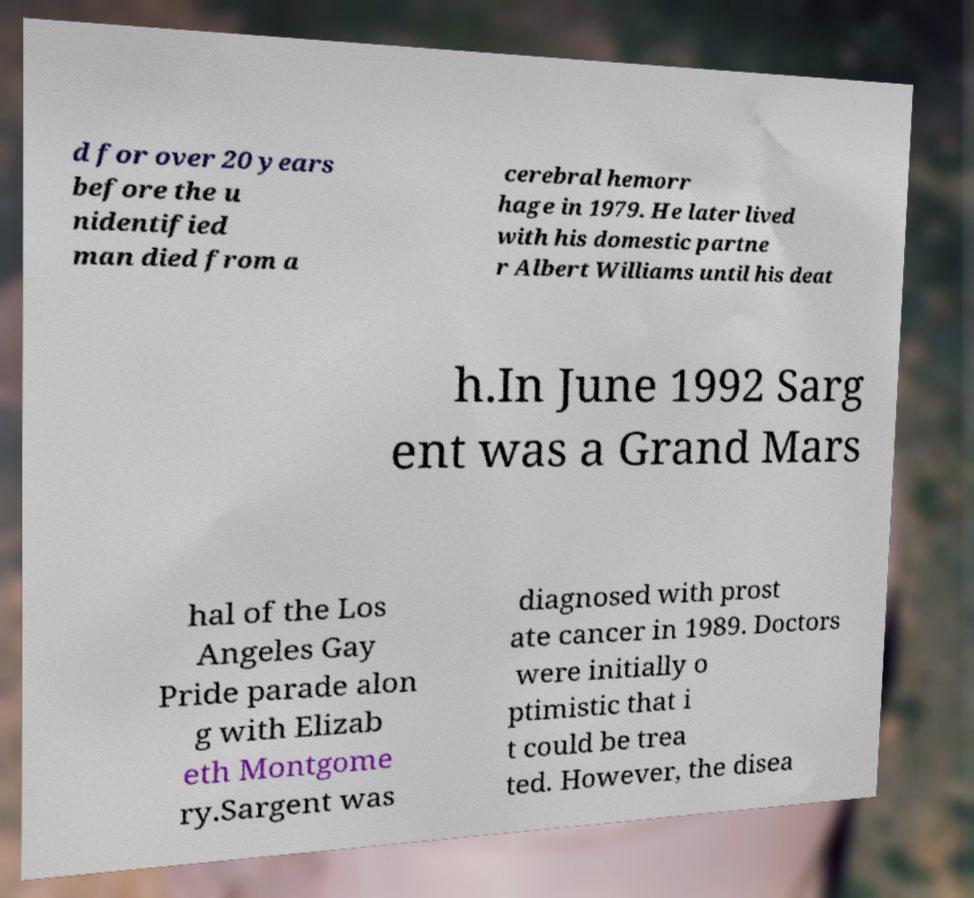Please identify and transcribe the text found in this image. d for over 20 years before the u nidentified man died from a cerebral hemorr hage in 1979. He later lived with his domestic partne r Albert Williams until his deat h.In June 1992 Sarg ent was a Grand Mars hal of the Los Angeles Gay Pride parade alon g with Elizab eth Montgome ry.Sargent was diagnosed with prost ate cancer in 1989. Doctors were initially o ptimistic that i t could be trea ted. However, the disea 